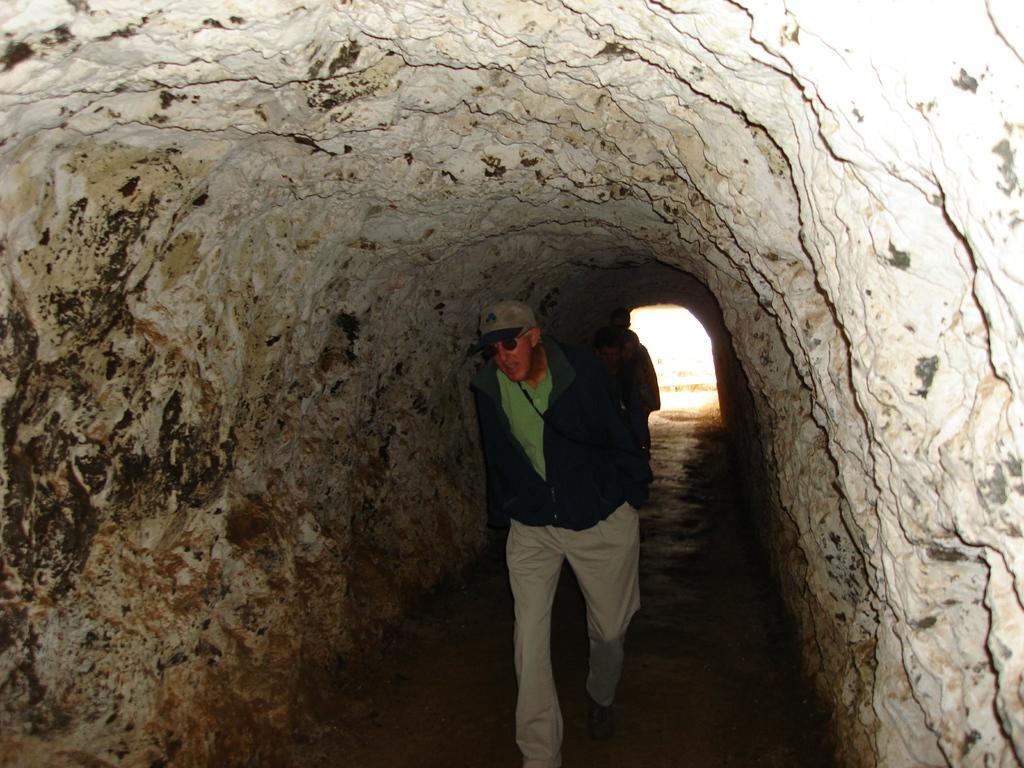Can you describe this image briefly? In this image we can see three people and a tunnel. 